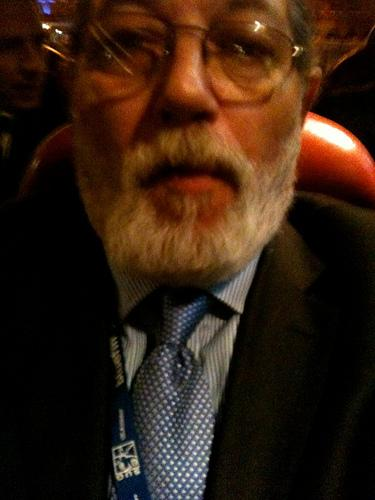The person wearing the blue tie looks most like whom? Please explain your reasoning. donald pleasence. The person looks like donald pleasance. 